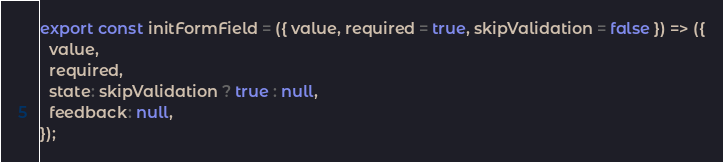<code> <loc_0><loc_0><loc_500><loc_500><_JavaScript_>export const initFormField = ({ value, required = true, skipValidation = false }) => ({
  value,
  required,
  state: skipValidation ? true : null,
  feedback: null,
});
</code> 